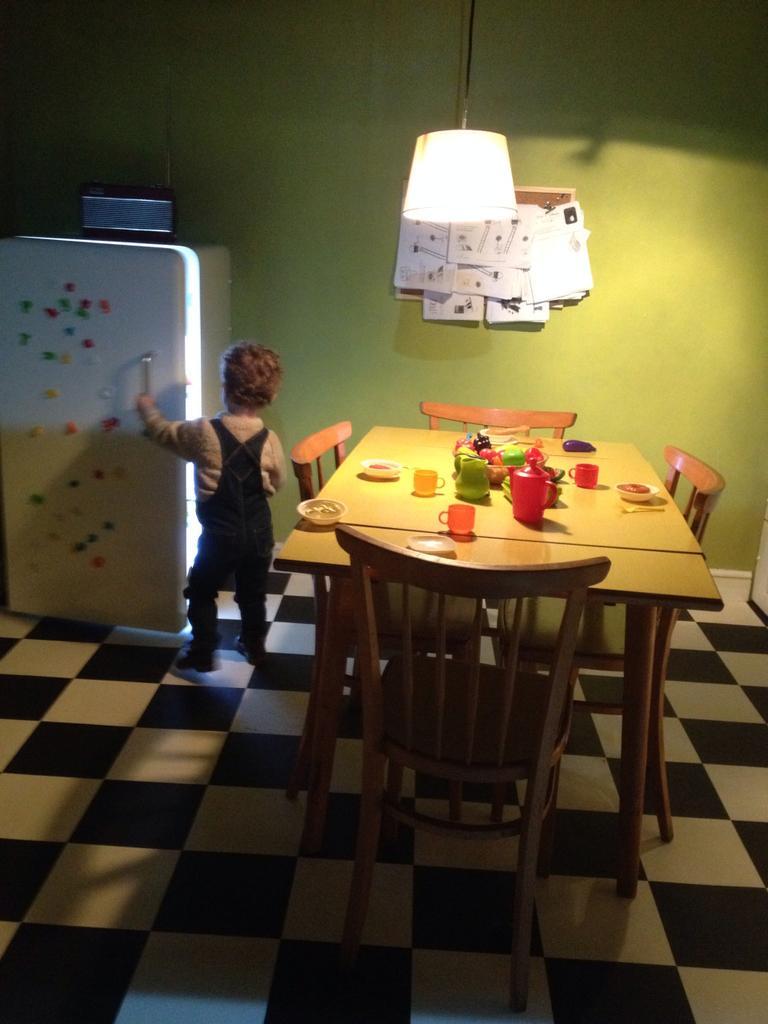How would you summarize this image in a sentence or two? This picture shows a boy standing and we see bottles and cups on the table and we see few trees around 